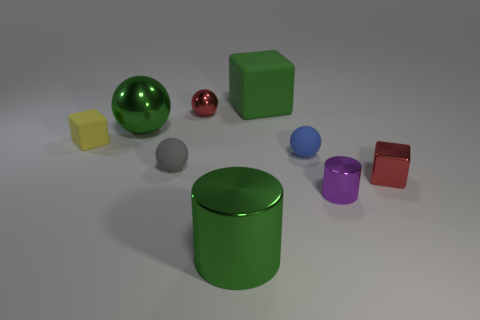There is a tiny rubber object behind the tiny blue thing; is there a tiny red ball to the left of it?
Ensure brevity in your answer.  No. Does the red metal thing that is on the left side of the big green rubber cube have the same shape as the gray thing?
Give a very brief answer. Yes. Are there any other things that have the same shape as the gray thing?
Your answer should be compact. Yes. How many cylinders are large rubber objects or small gray things?
Your answer should be very brief. 0. How many gray rubber spheres are there?
Make the answer very short. 1. What is the size of the green metal object in front of the matte cube in front of the green block?
Provide a short and direct response. Large. How many other objects are there of the same size as the purple metallic thing?
Your response must be concise. 5. What number of blue things are right of the small rubber cube?
Provide a short and direct response. 1. How big is the red ball?
Make the answer very short. Small. Does the red object on the left side of the tiny blue matte ball have the same material as the small block that is left of the purple shiny cylinder?
Ensure brevity in your answer.  No. 